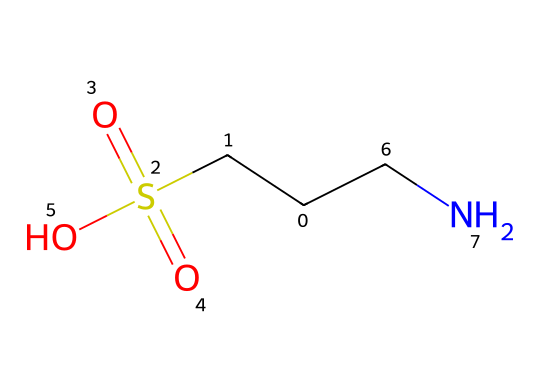What is the name of this chemical? The SMILES representation given corresponds to taurine, which is a sulfur-containing amino acid. It is commonly known and recognized within biochemical contexts.
Answer: taurine How many sulfur atoms are present in taurine? By analyzing the structure indicated in the SMILES, we see there is one 'S' in the formula, representing one sulfur atom.
Answer: 1 What functional group is present due to the sulfur atom? The structure shows that the sulfur is part of a sulfonic acid group (-S(=O)(=O)O), which is characteristic of sulfur compounds.
Answer: sulfonic acid What is the total number of carbon atoms in taurine? In the provided SMILES representation, there are three 'C' characters, indicating a total of three carbon atoms in the structure.
Answer: 3 What type of bonding does sulfur typically exhibit in taurine? The sulfur atom in taurine forms a double bond with two oxygen atoms (as seen in the sulfonic group), indicative of its ability to exhibit double bonding characteristics.
Answer: double bond Is taurine hydrophilic or hydrophobic? Due to the presence of sulfonic acid and amino groups, which can form hydrogen bonds with water, taurine is considered hydrophilic.
Answer: hydrophilic What type of molecule is taurine classified as? Taurine is classified as a beta-amino acid because of the placement of the amino group relative to the carboxyl group; it differs from standard amino acids.
Answer: beta-amino acid 